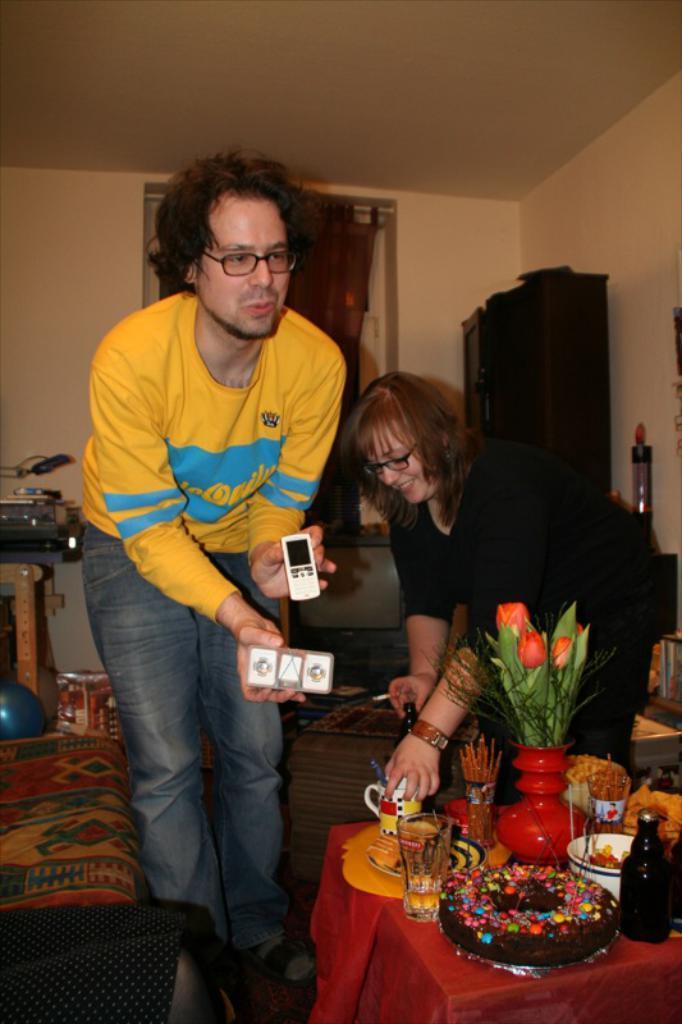Please provide a concise description of this image. This image is taken indoors. At the top of the image there is a ceiling. In the background there is a wall with a door. There is a television on the table. In the middle of the image a man is standing on the floor and he is holding a mobile phone and a toy in his hand. On the right side of the image a woman is standing on the floor and there is a cupboard. On the left side of the image there is a bed and a table with a few things on it. At the bottom of the image there is a table with a tablecloth, flower vase and many food items on it. 